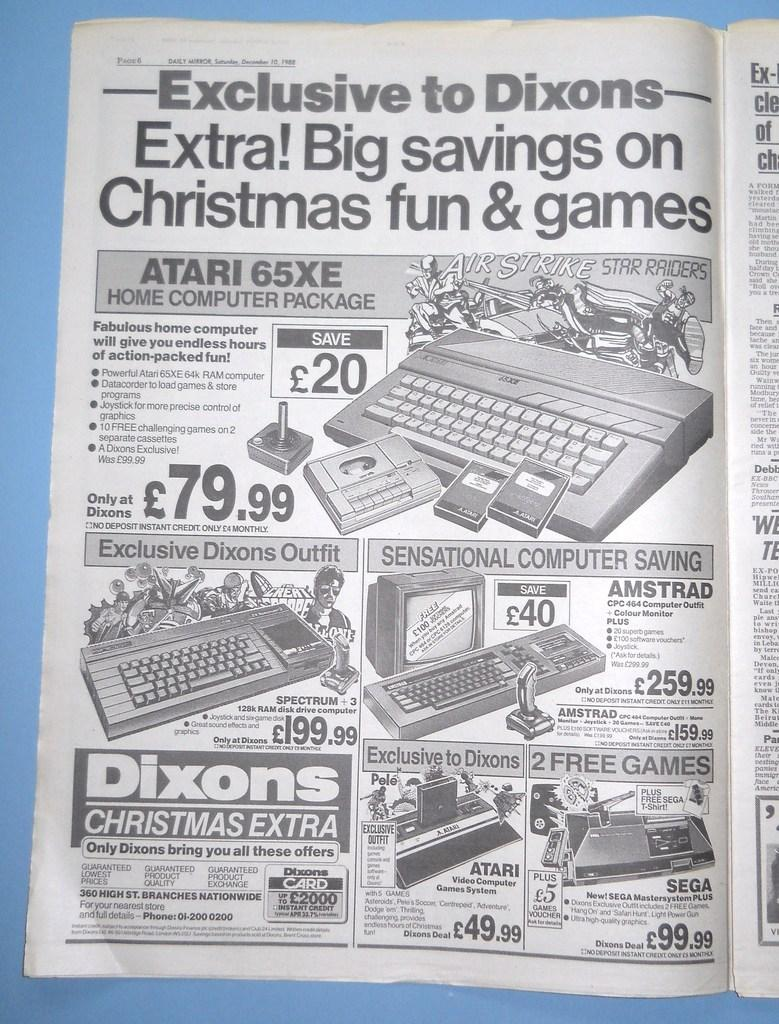<image>
Relay a brief, clear account of the picture shown. A magazine with the page "Exclusive to Dixons" as the headline. 